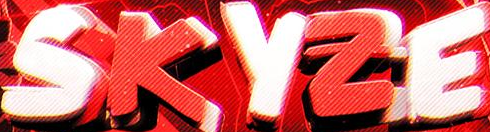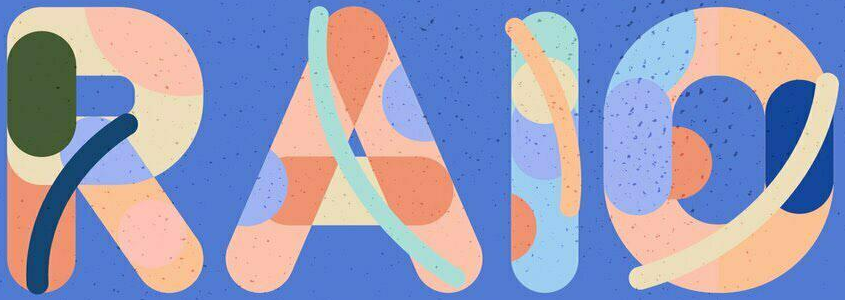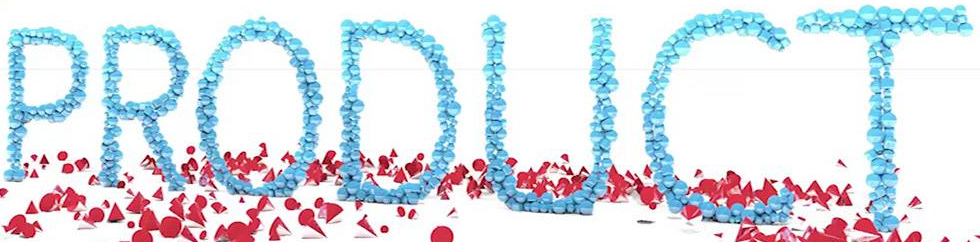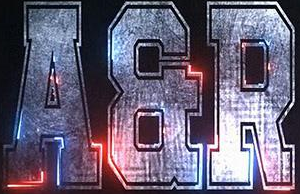What words are shown in these images in order, separated by a semicolon? SKYZE; RAIO; PRODUCT; AER 